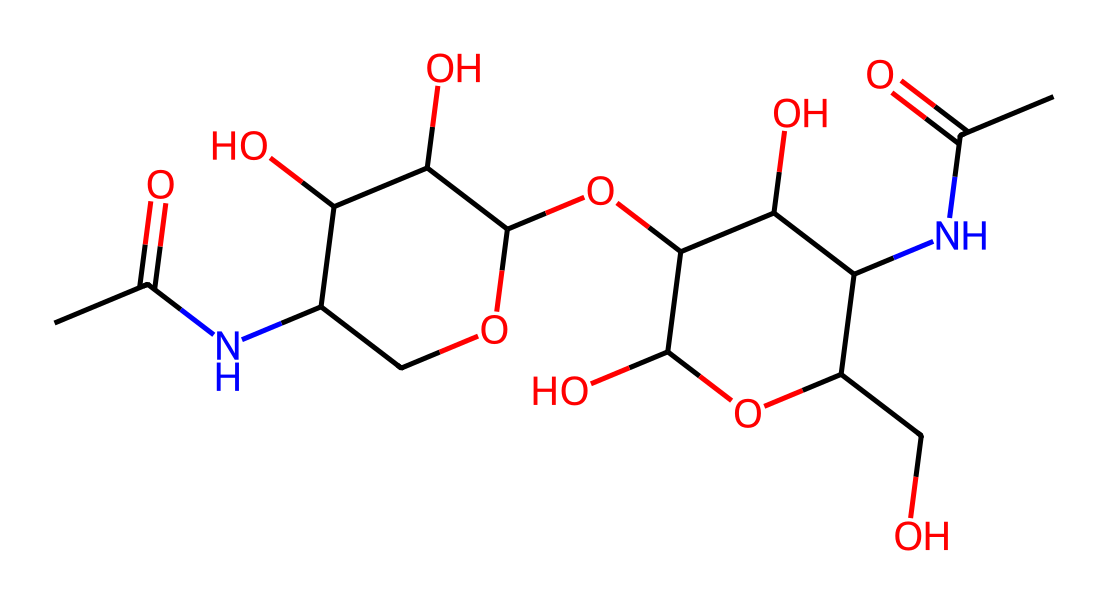What is the main component of insect exoskeletons found in this structure? The structure represented in the SMILES corresponds to chitin, which is a polysaccharide and provides structural support in the exoskeletons of insects.
Answer: chitin How many carbon atoms are present in the chemical structure? By analyzing the SMILES, we can count the carbon atoms individually. In this representation, there are a total of 12 carbon atoms.
Answer: 12 What functional group is present in this compound that suggests it's a polymer? The presence of multiple hydroxyl (–OH) groups along with the repeated structural units indicates that this compound is a polymer, specifically having multiple –OH groups contributing to its polymeric nature.
Answer: hydroxyl group What type of bond connects most of the carbon atoms in this molecule? The majority of the carbon atoms in this structure are connected by single bonds, which is characteristic of aliphatic chains found in polysaccharides like chitin.
Answer: single bond Which atoms contribute to the nitrogen content of the structure? From the SMILES, there are two nitrogen atoms present, which suggest that the structure has amide functional groups indicative of the nitrogen content in the polymer backbone.
Answer: two nitrogen atoms What is the primary role of the –NH group in the structure? The –NH group indicates the presence of amide linkages, which play a crucial role in providing stability and strength to chitin's structural framework in insect exoskeletons.
Answer: amide linkages 